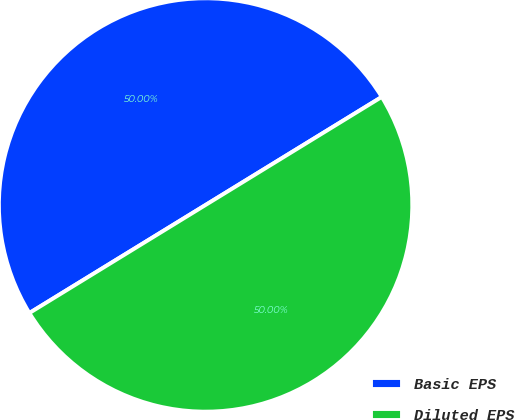Convert chart. <chart><loc_0><loc_0><loc_500><loc_500><pie_chart><fcel>Basic EPS<fcel>Diluted EPS<nl><fcel>50.0%<fcel>50.0%<nl></chart> 